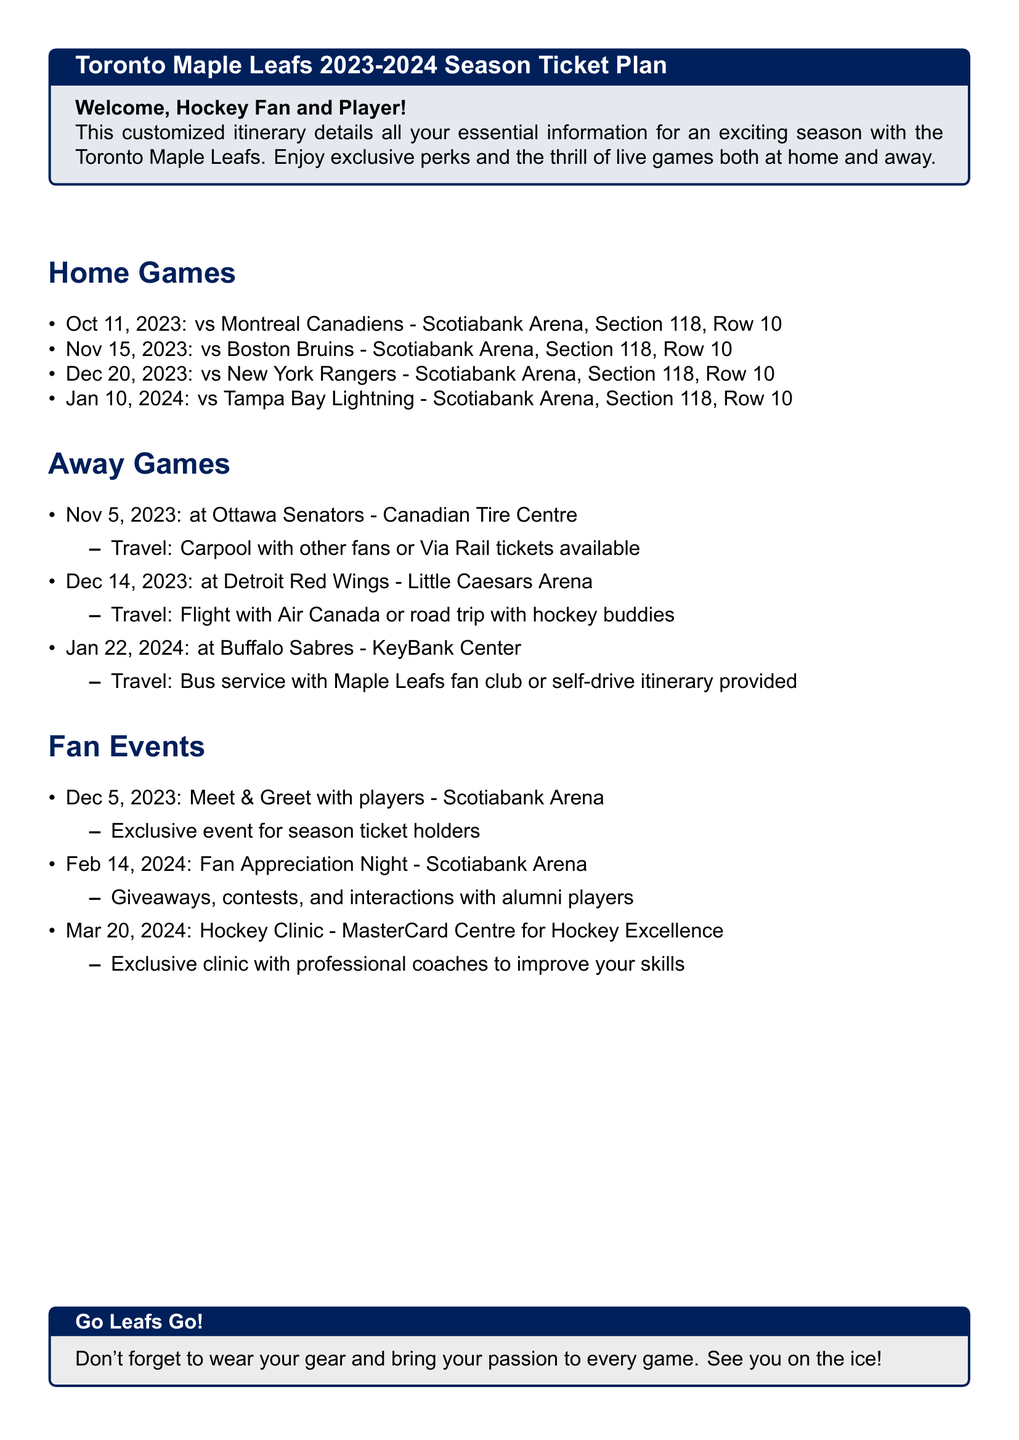What is the first home game date? The first home game is against the Montreal Canadiens, held on October 11, 2023.
Answer: October 11, 2023 Where is the away game against the Buffalo Sabres? The document states the location for the away game against the Buffalo Sabres is at KeyBank Center.
Answer: KeyBank Center What travel option is suggested for the away game at Ottawa Senators? The itinerary mentions carpooling or Via Rail tickets as travel options for this away game.
Answer: Carpool or Via Rail How many home games are listed in the itinerary? The document lists four home games scheduled for the season.
Answer: Four What type of event is held on December 5, 2023? The event scheduled on December 5 is a Meet & Greet with players for season ticket holders.
Answer: Meet & Greet Who can attend the fan appreciation night? The document specifies that the fan appreciation night is for all fans, but primarily targeted at season ticket holders.
Answer: Season ticket holders What is the location of the Hockey Clinic? This clinic is held at the MasterCard Centre for Hockey Excellence, according to the information in the itinerary.
Answer: MasterCard Centre for Hockey Excellence What is the significance of the date February 14, 2024? This date is notable for the Fan Appreciation Night, which includes various activities for fans.
Answer: Fan Appreciation Night 